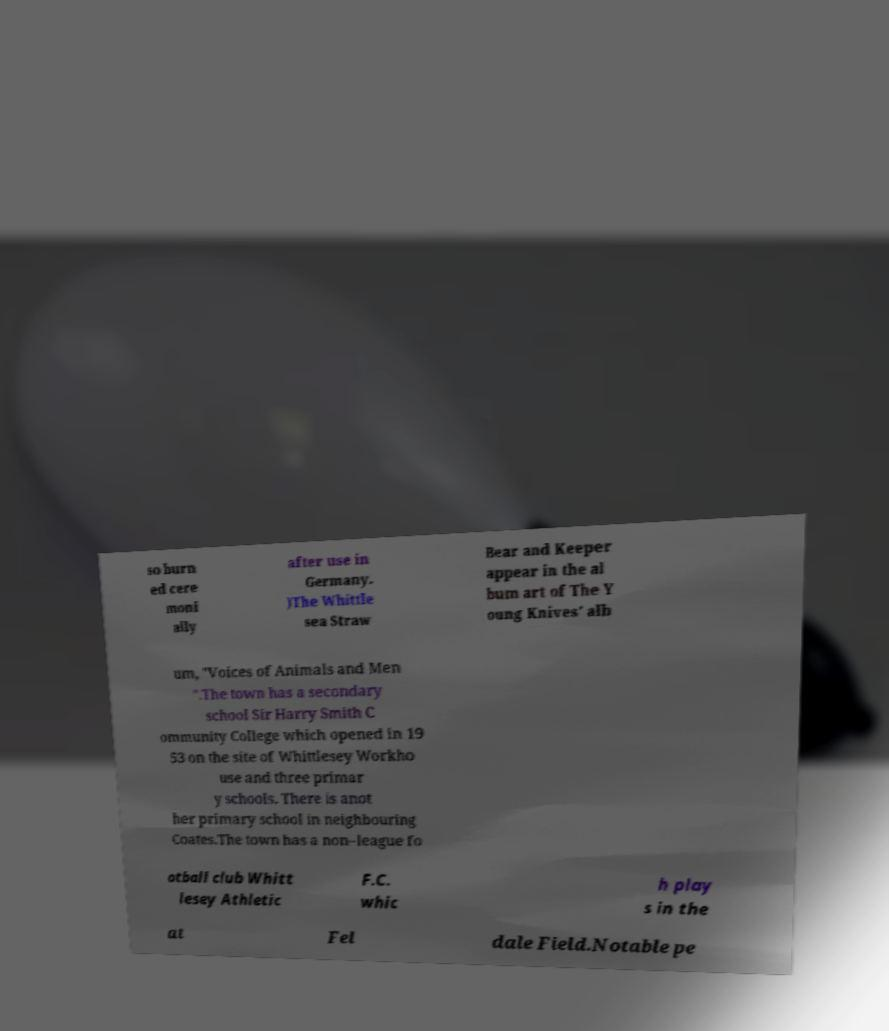Could you assist in decoding the text presented in this image and type it out clearly? so burn ed cere moni ally after use in Germany. )The Whittle sea Straw Bear and Keeper appear in the al bum art of The Y oung Knives' alb um, "Voices of Animals and Men ".The town has a secondary school Sir Harry Smith C ommunity College which opened in 19 53 on the site of Whittlesey Workho use and three primar y schools. There is anot her primary school in neighbouring Coates.The town has a non–league fo otball club Whitt lesey Athletic F.C. whic h play s in the at Fel dale Field.Notable pe 